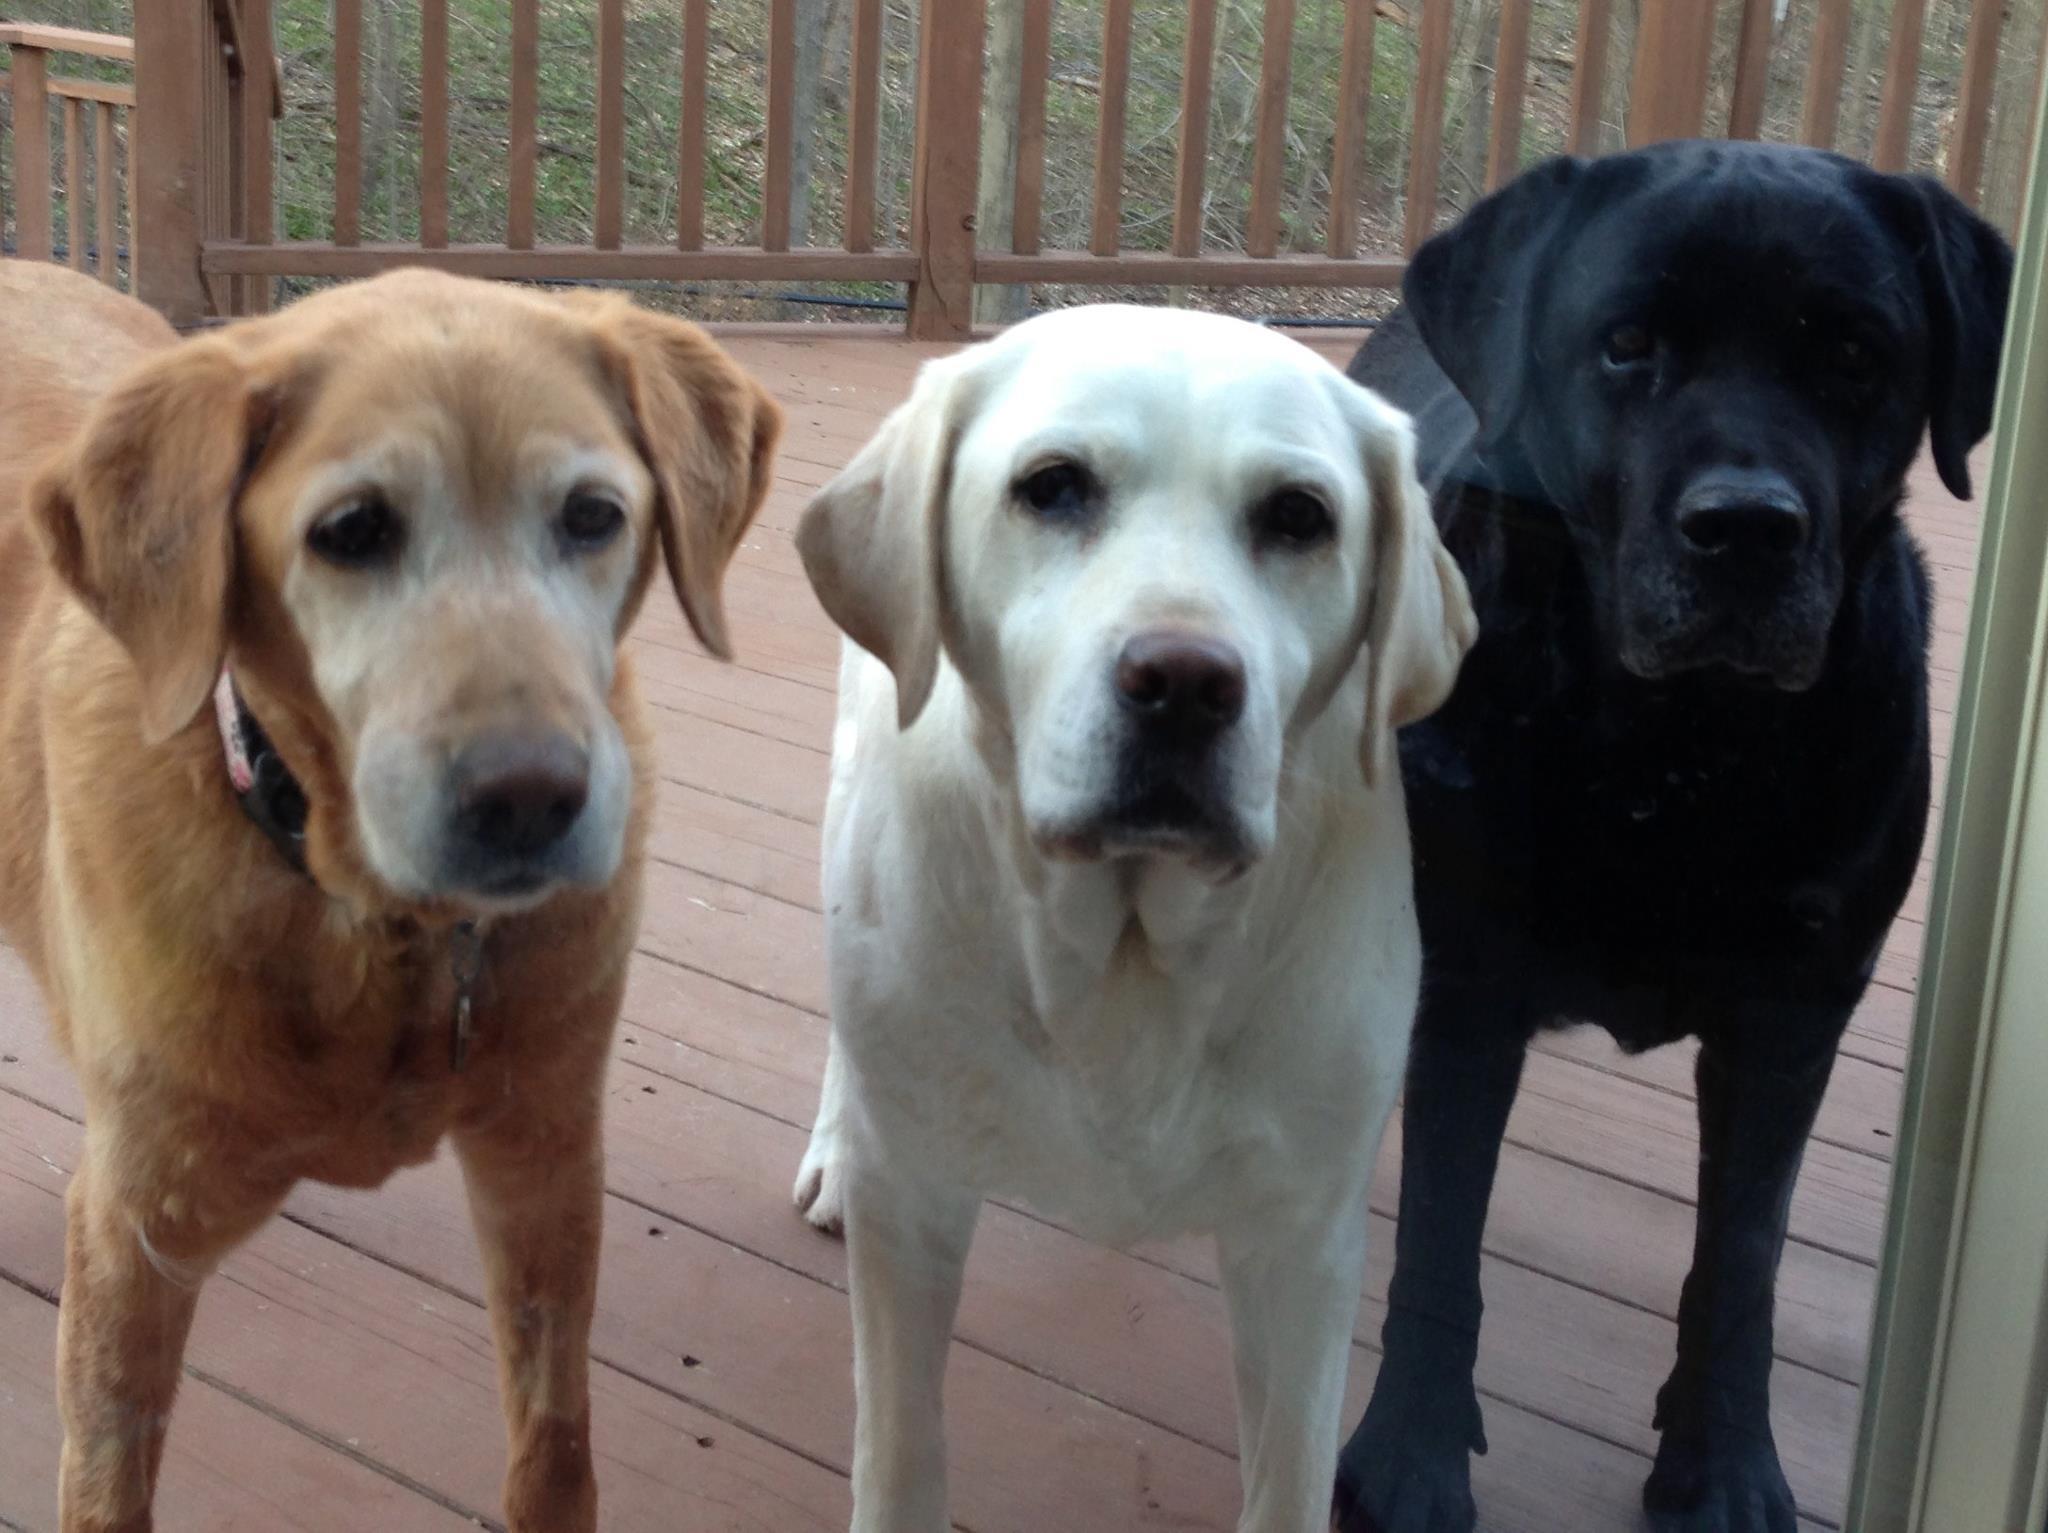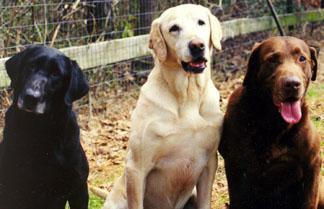The first image is the image on the left, the second image is the image on the right. Assess this claim about the two images: "The right image has a black dog furthest to the left that is seated next to a white dog.". Correct or not? Answer yes or no. Yes. 